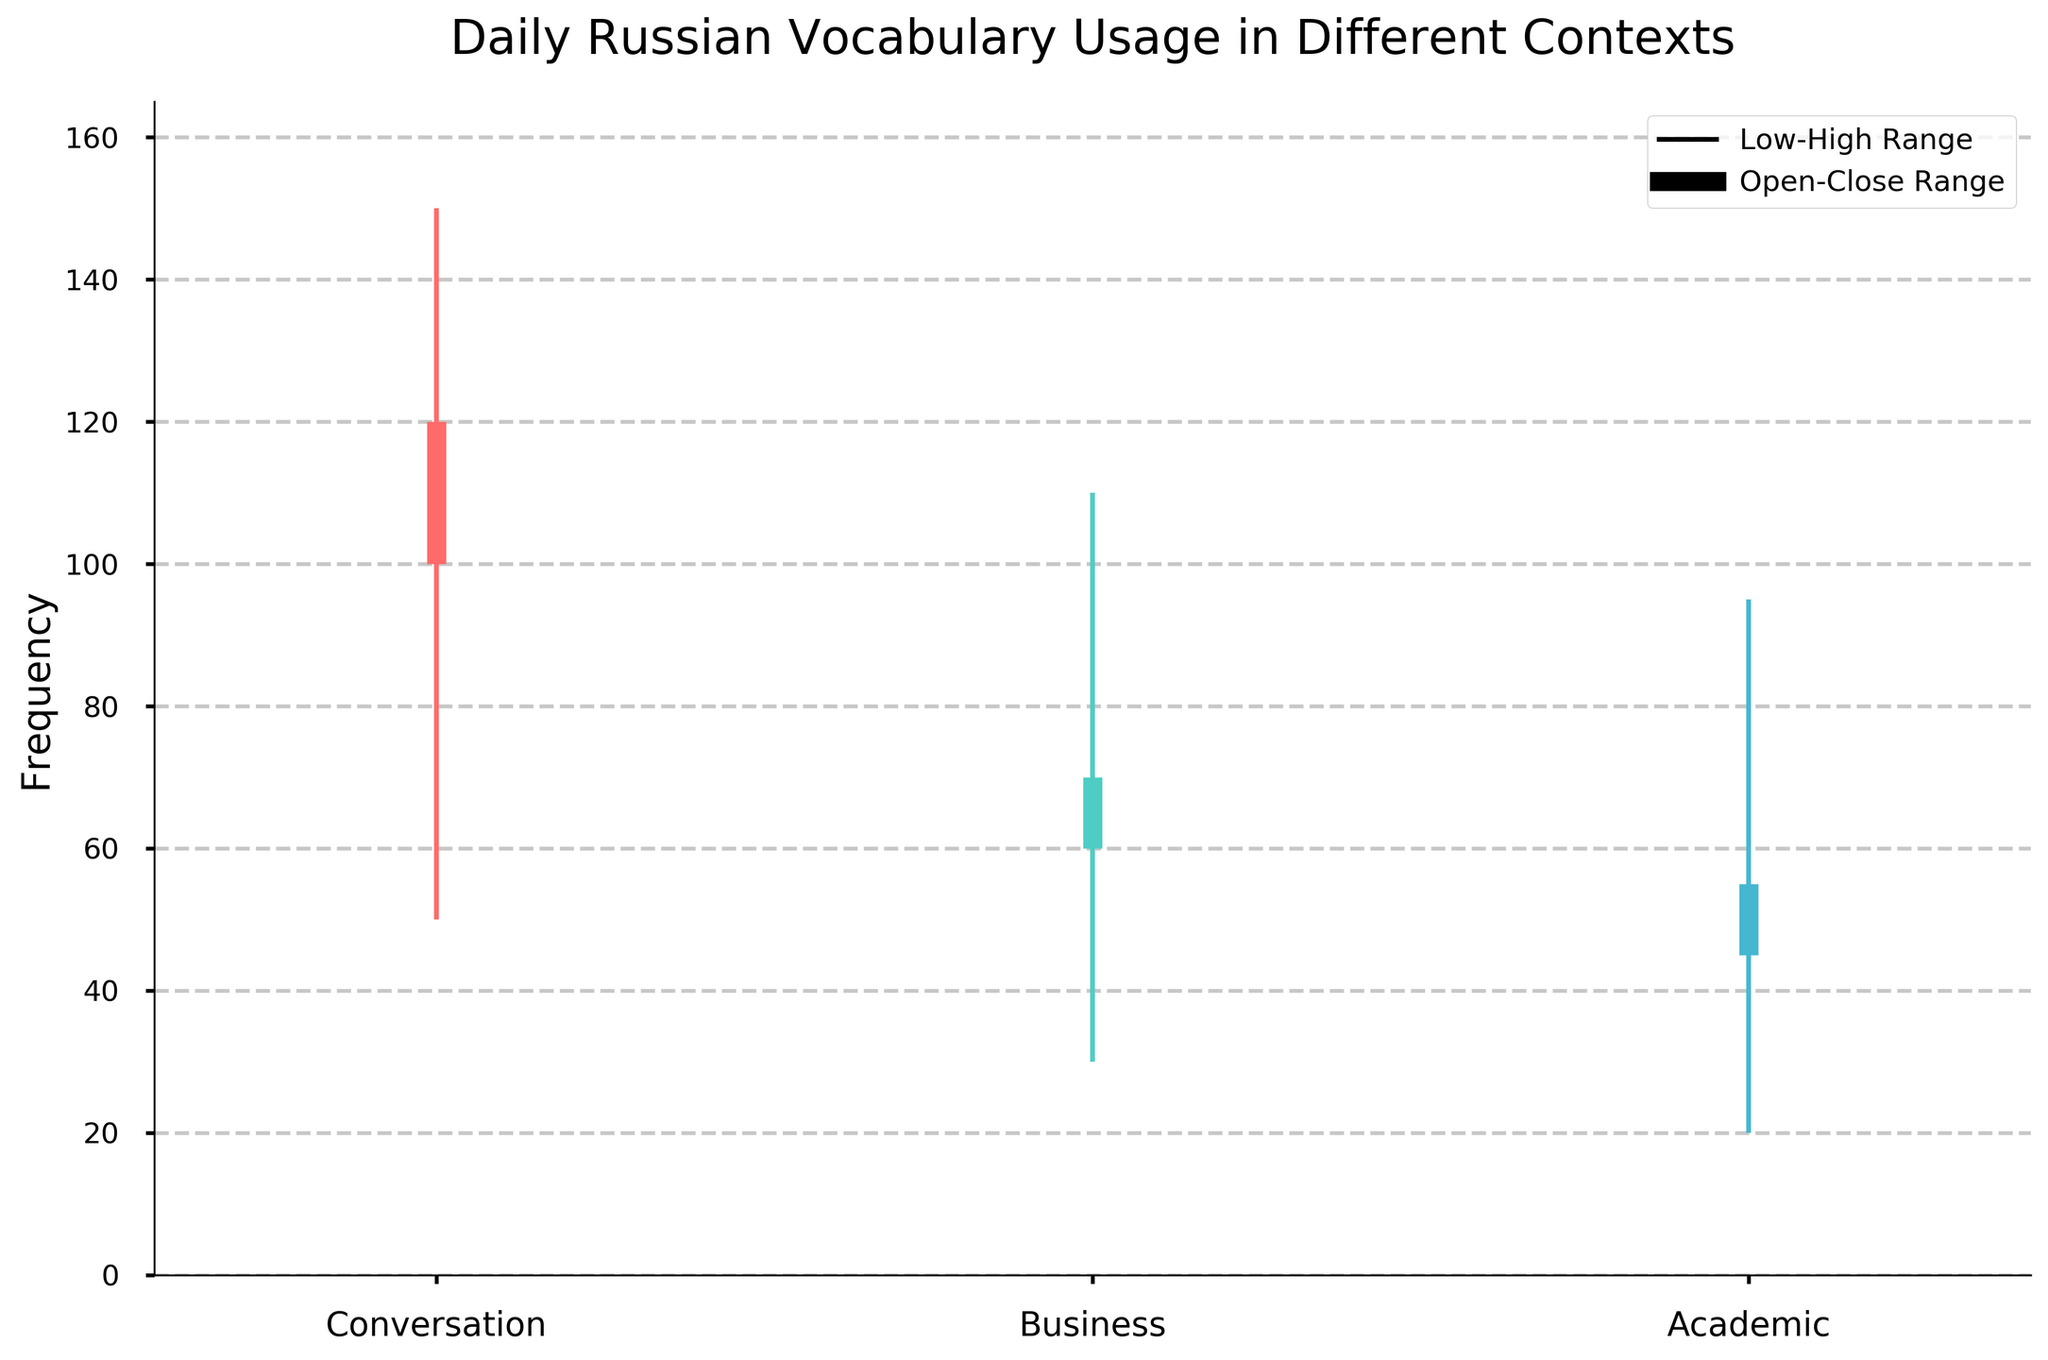What is the title of the plot? The title is written at the top of the plot, providing a summary of what the figure represents.
Answer: Daily Russian Vocabulary Usage in Different Contexts What are the contexts considered in the plot? The contexts are labeled on the x-axis below the plot's candlesticks.
Answer: Conversation, Business, Academic Which context has the highest daily vocabulary usage in any scenario? By looking at the highest vertical line among the candlesticks, we can see which context reaches the highest point. The 'Conversation' context reaches 150, which is the highest.
Answer: Conversation What is the range of vocabulary usage for the 'Business' context? The range is given by the difference between the highest and lowest values for the 'Business' context. Here, it's 110 (High) - 30 (Low).
Answer: 80 In which context is there the smallest difference between the opening and closing usage values? Calculate the difference between the opening and closing values for each context and compare them: 
  - Conversation: 120 - 100 = 20
  - Business: 70 - 60 = 10
  - Academic: 55 - 45 = 10. Since Business and Academic both have a difference of 10, either can be the correct answer.
Answer: Business and Academic What can be inferred if the close is higher than the open in the candlestick plot? The color and thickness of the candlestick indicate if the close is higher than the open. A filled thicker candlestick means an increase in usage from open to close. When close is higher, it indicates vocabulary usage increased over the day.
Answer: Vocabulary usage increased Which context shows a decrease in daily vocabulary usage based on the open and close values? Check if the close value is less than the open value for each context. 'Conversation' shows a close value of 100 and an open of 120, indicating a decrease during the day.
Answer: Conversation What is the average high value for the three contexts? Calculate the average of the high values for Conversation, Business, and Academic. (150 + 110 + 95)/3 = 355/3
Answer: 118.33 Which context has the widest range of vocabulary usage? Compare the range for each context by subtracting the low value from the high:
  - Conversation: 150 - 50 = 100 
  - Business: 110 - 30 = 80
  - Academic: 95 - 20 = 75. The 'Conversation' context has the widest range.
Answer: Conversation 